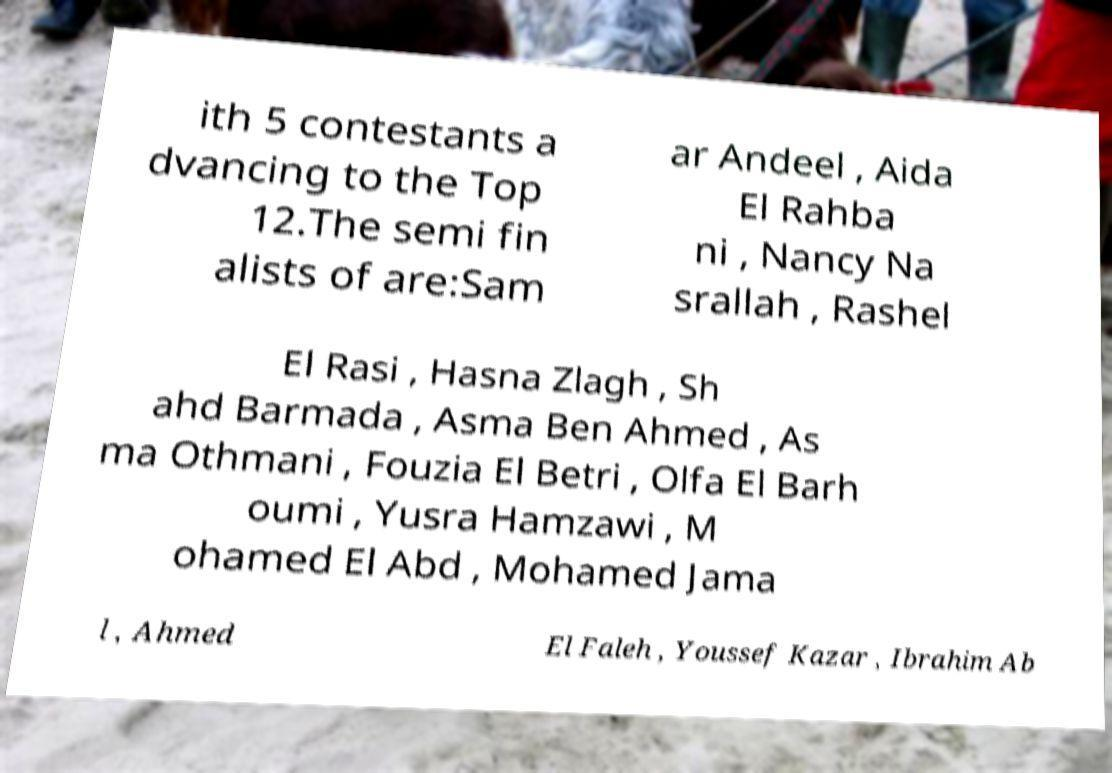Could you assist in decoding the text presented in this image and type it out clearly? ith 5 contestants a dvancing to the Top 12.The semi fin alists of are:Sam ar Andeel , Aida El Rahba ni , Nancy Na srallah , Rashel El Rasi , Hasna Zlagh , Sh ahd Barmada , Asma Ben Ahmed , As ma Othmani , Fouzia El Betri , Olfa El Barh oumi , Yusra Hamzawi , M ohamed El Abd , Mohamed Jama l , Ahmed El Faleh , Youssef Kazar , Ibrahim Ab 